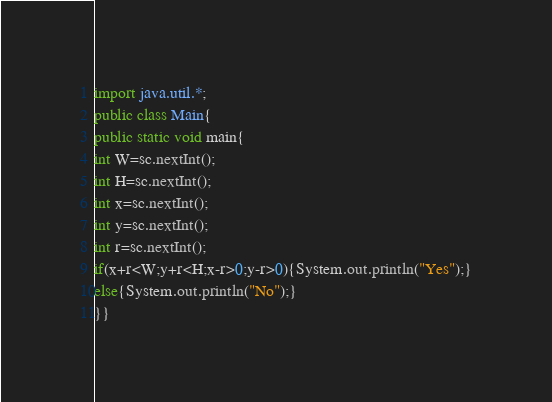<code> <loc_0><loc_0><loc_500><loc_500><_Java_>import java.util.*;
public class Main{
public static void main{
int W=sc.nextInt();
int H=sc.nextInt();
int x=sc.nextInt();
int y=sc.nextInt();
int r=sc.nextInt();
if(x+r<W;y+r<H;x-r>0;y-r>0){System.out.println("Yes");}
else{System.out.println("No");}
}}</code> 